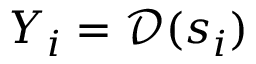Convert formula to latex. <formula><loc_0><loc_0><loc_500><loc_500>Y _ { i } = \mathcal { D } ( { s _ { i } } )</formula> 